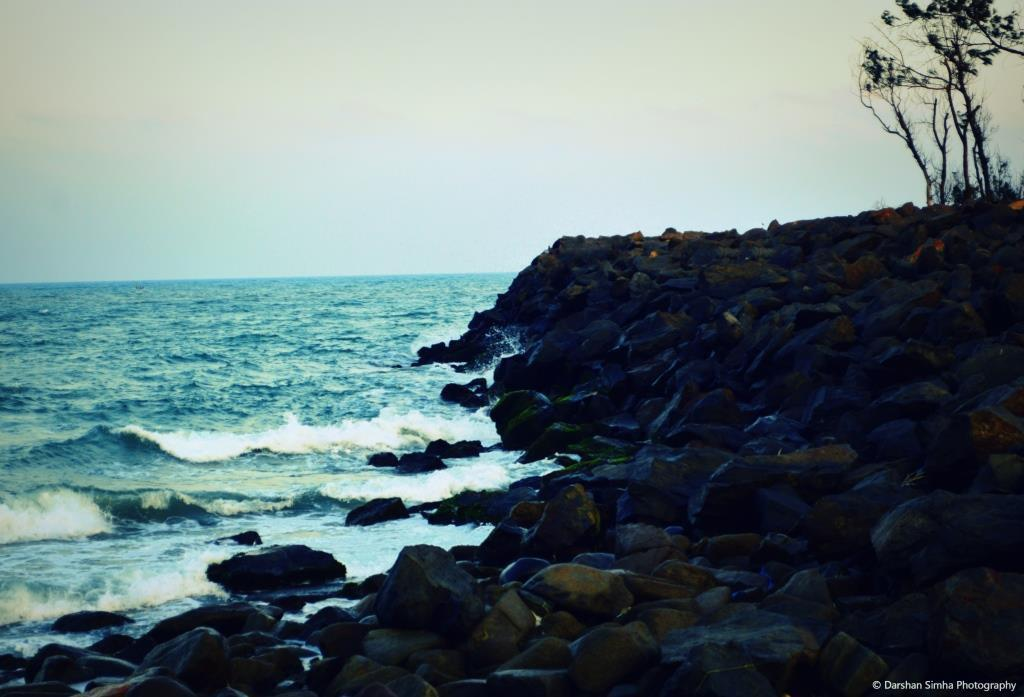What is the primary element visible in the image? There is water in the image. What other objects or features can be seen in the image? There are rocks and trees visible in the image. What can be seen in the background of the image? The sky is visible in the background of the image. What type of verse is being recited by the coach in the image? There is no coach or verse present in the image. 